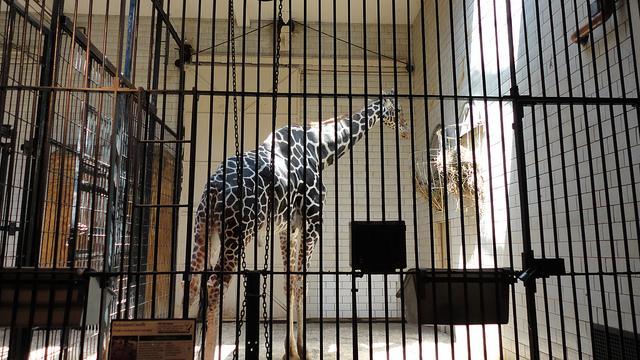Is this a happy animal?
Give a very brief answer. No. Is this animal free?
Short answer required. No. Where is the picture taken?
Be succinct. Zoo. 